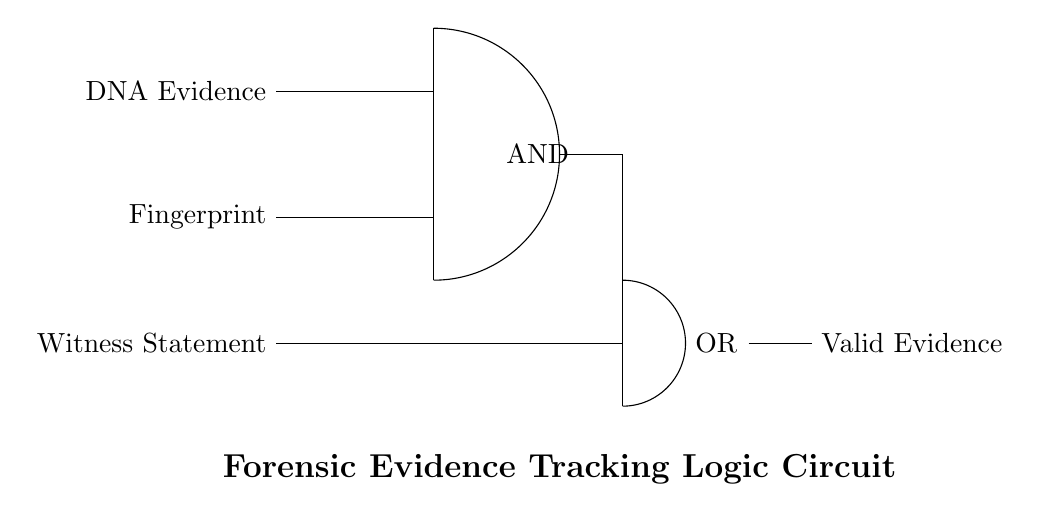What are the three inputs to the AND gate? The three inputs are DNA Evidence, Fingerprint, and Witness Statement. The AND gate specifically combines the DNA Evidence and Fingerprint inputs.
Answer: DNA Evidence and Fingerprint What is the output of the OR gate? The output from the OR gate is "Valid Evidence." The OR gate processes the input from the AND gate and the Witness Statement, giving a true output if any of its inputs are true.
Answer: Valid Evidence How many gates are used in the circuit? There are two gates used in the circuit: one AND gate and one OR gate.
Answer: Two What is the function of the AND gate in this circuit? The function of the AND gate is to require both DNA Evidence and Fingerprint inputs to be present (true) to yield a true output. This ensures that only strong evidence is considered valid.
Answer: Combination What kind of logic does the OR gate implement? The OR gate implements inclusive logic, where the output is true if at least one of the inputs is true. This allows for flexibility in considering the evidence collected.
Answer: Inclusive Which components are connected to the OR gate? The components connected to the OR gate are the output of the AND gate and the input witness statement. It ensures that either input can result in valid evidence.
Answer: AND gate and Witness Statement 